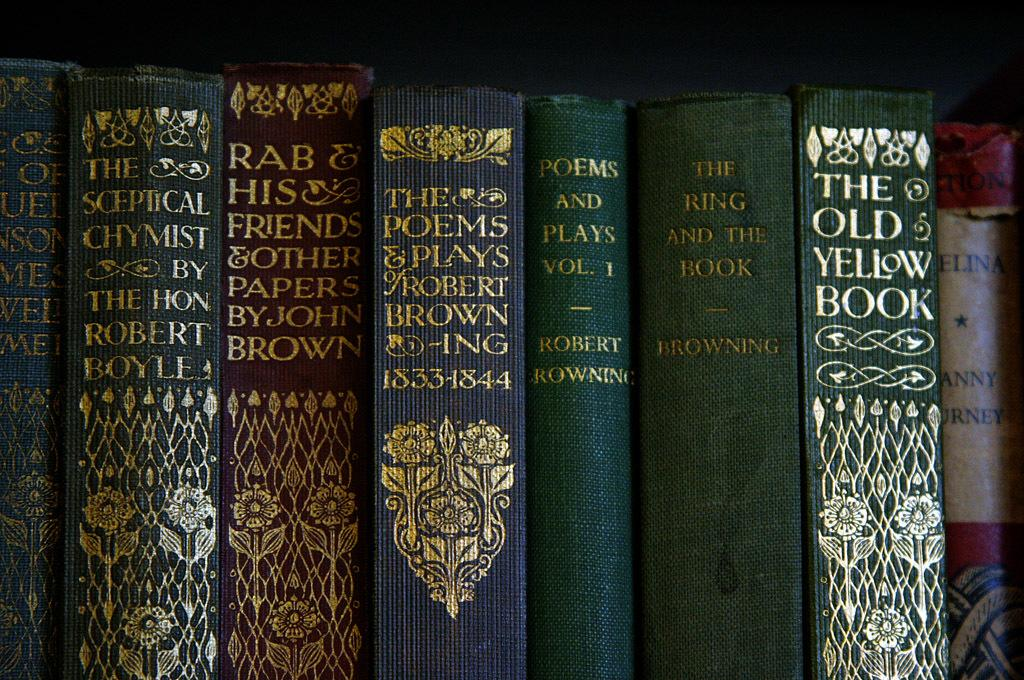<image>
Offer a succinct explanation of the picture presented. A set of books with at least more than one by somebody with the surname Browning. 